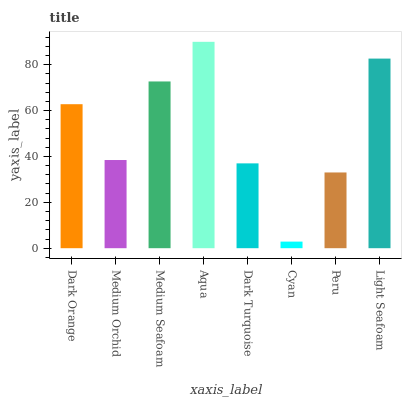Is Cyan the minimum?
Answer yes or no. Yes. Is Aqua the maximum?
Answer yes or no. Yes. Is Medium Orchid the minimum?
Answer yes or no. No. Is Medium Orchid the maximum?
Answer yes or no. No. Is Dark Orange greater than Medium Orchid?
Answer yes or no. Yes. Is Medium Orchid less than Dark Orange?
Answer yes or no. Yes. Is Medium Orchid greater than Dark Orange?
Answer yes or no. No. Is Dark Orange less than Medium Orchid?
Answer yes or no. No. Is Dark Orange the high median?
Answer yes or no. Yes. Is Medium Orchid the low median?
Answer yes or no. Yes. Is Peru the high median?
Answer yes or no. No. Is Dark Turquoise the low median?
Answer yes or no. No. 